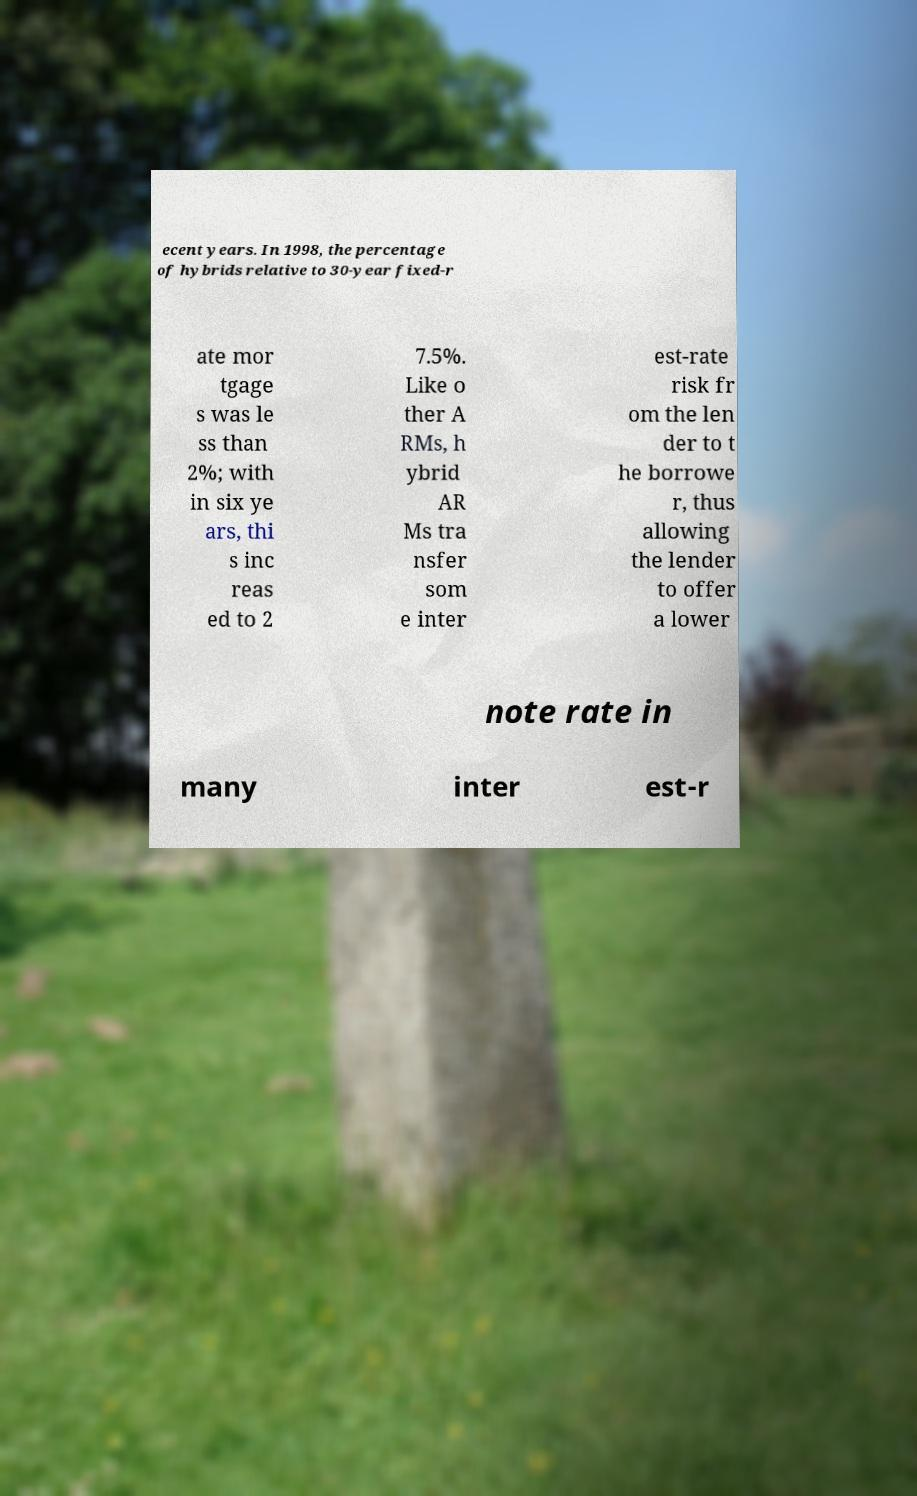Could you assist in decoding the text presented in this image and type it out clearly? ecent years. In 1998, the percentage of hybrids relative to 30-year fixed-r ate mor tgage s was le ss than 2%; with in six ye ars, thi s inc reas ed to 2 7.5%. Like o ther A RMs, h ybrid AR Ms tra nsfer som e inter est-rate risk fr om the len der to t he borrowe r, thus allowing the lender to offer a lower note rate in many inter est-r 